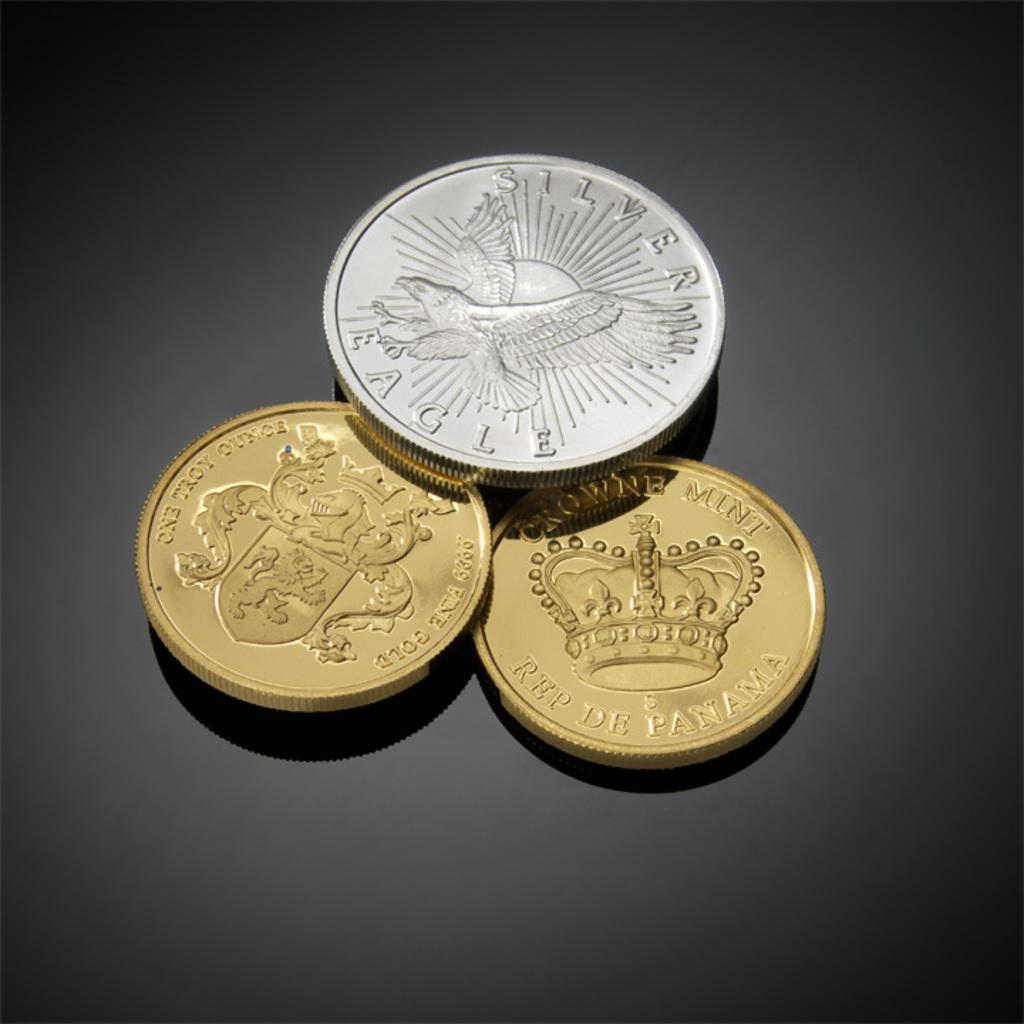<image>
Offer a succinct explanation of the picture presented. Three coins sit on table one is a silver eagle. 